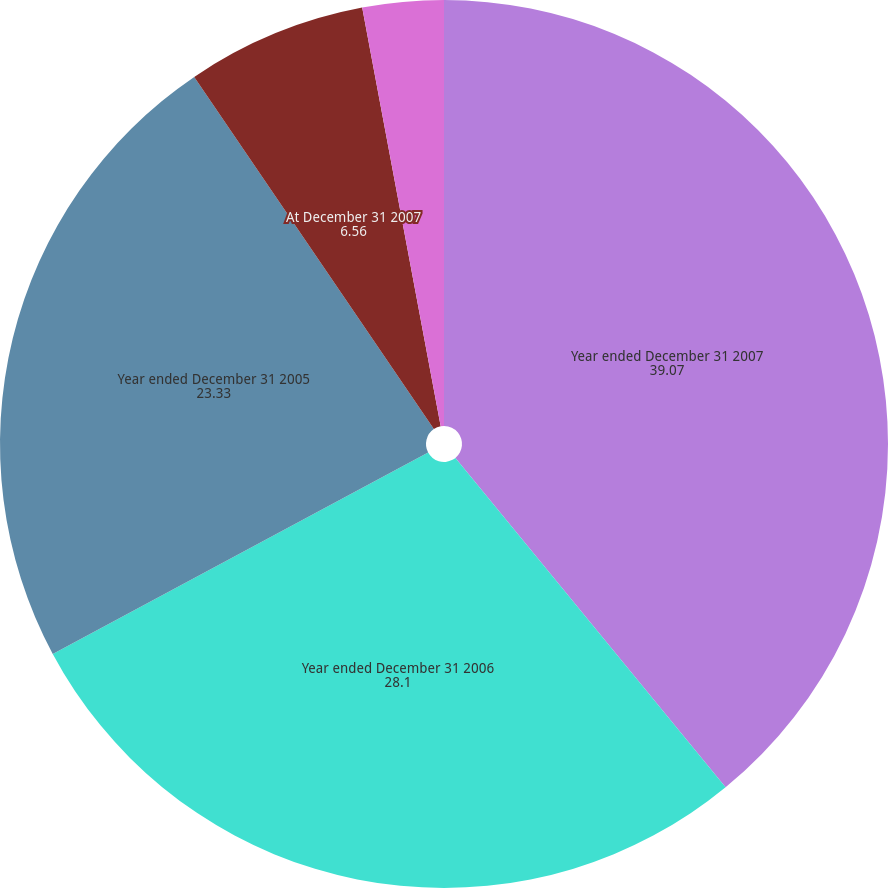<chart> <loc_0><loc_0><loc_500><loc_500><pie_chart><fcel>Year ended December 31 2007<fcel>Year ended December 31 2006<fcel>Year ended December 31 2005<fcel>At December 31 2007<fcel>At December 31 2006<nl><fcel>39.07%<fcel>28.1%<fcel>23.33%<fcel>6.56%<fcel>2.95%<nl></chart> 